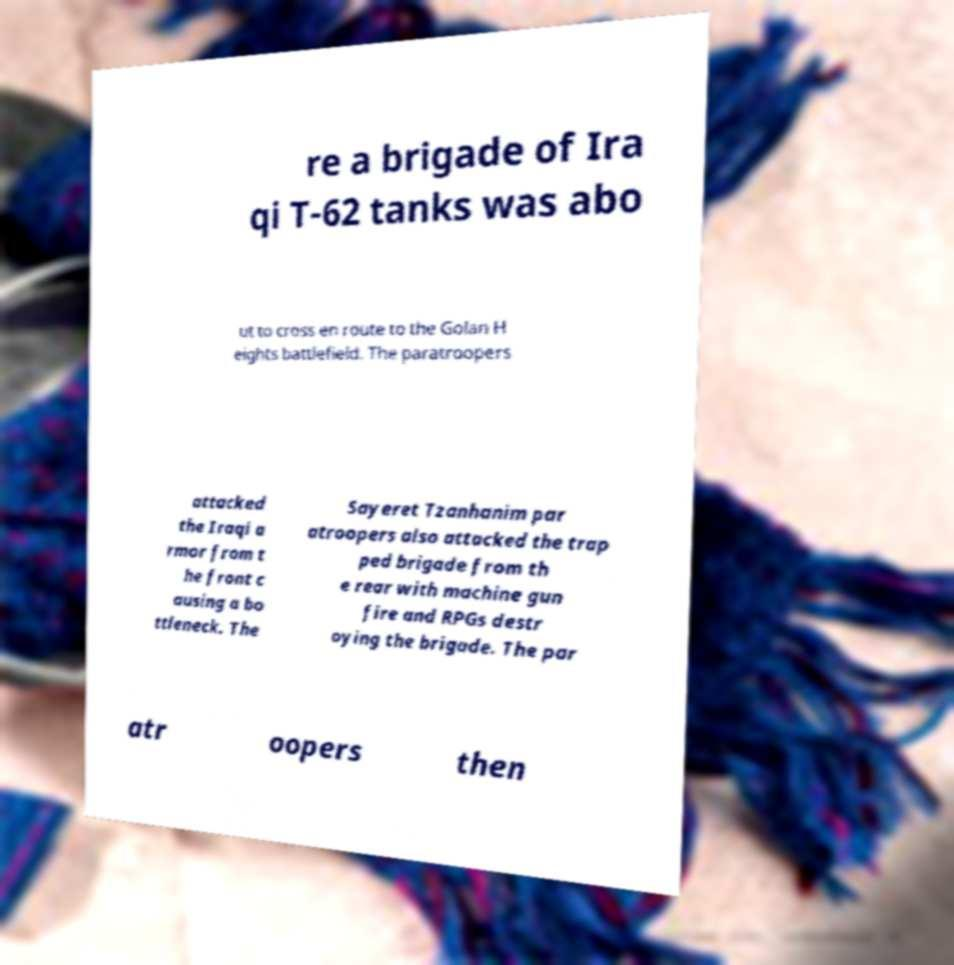Could you assist in decoding the text presented in this image and type it out clearly? re a brigade of Ira qi T-62 tanks was abo ut to cross en route to the Golan H eights battlefield. The paratroopers attacked the Iraqi a rmor from t he front c ausing a bo ttleneck. The Sayeret Tzanhanim par atroopers also attacked the trap ped brigade from th e rear with machine gun fire and RPGs destr oying the brigade. The par atr oopers then 